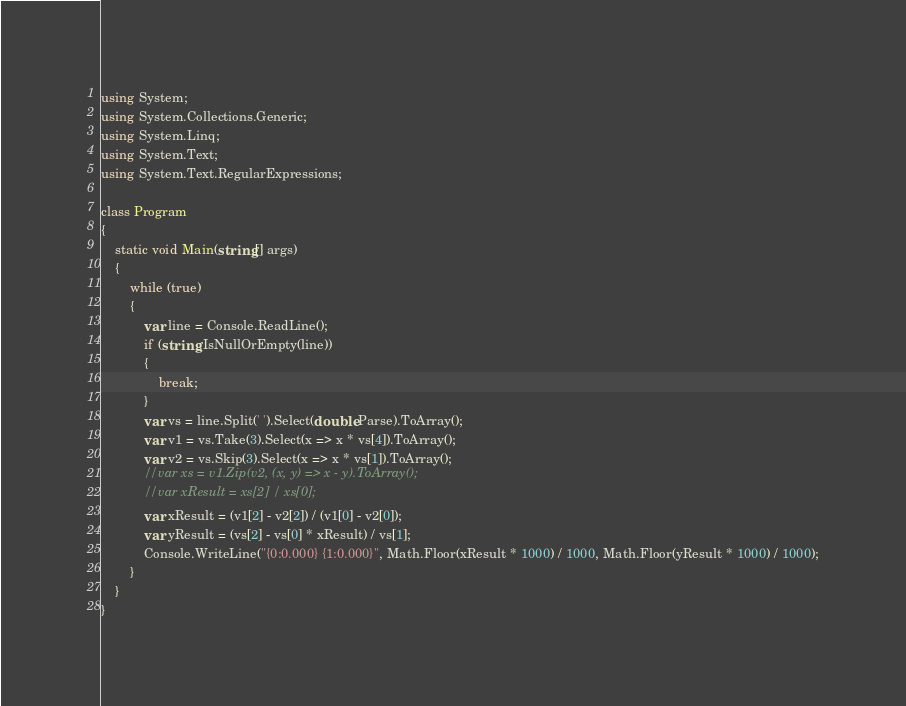Convert code to text. <code><loc_0><loc_0><loc_500><loc_500><_C#_>using System;
using System.Collections.Generic;
using System.Linq;
using System.Text;
using System.Text.RegularExpressions;
 
class Program
{
    static void Main(string[] args)
    {
        while (true)
        {
            var line = Console.ReadLine();
            if (string.IsNullOrEmpty(line))
            {
                break;
            }
            var vs = line.Split(' ').Select(double.Parse).ToArray();
            var v1 = vs.Take(3).Select(x => x * vs[4]).ToArray();
            var v2 = vs.Skip(3).Select(x => x * vs[1]).ToArray();
            //var xs = v1.Zip(v2, (x, y) => x - y).ToArray();
            //var xResult = xs[2] / xs[0];
            var xResult = (v1[2] - v2[2]) / (v1[0] - v2[0]);
            var yResult = (vs[2] - vs[0] * xResult) / vs[1];
            Console.WriteLine("{0:0.000} {1:0.000}", Math.Floor(xResult * 1000) / 1000, Math.Floor(yResult * 1000) / 1000);
        }
    }
}</code> 